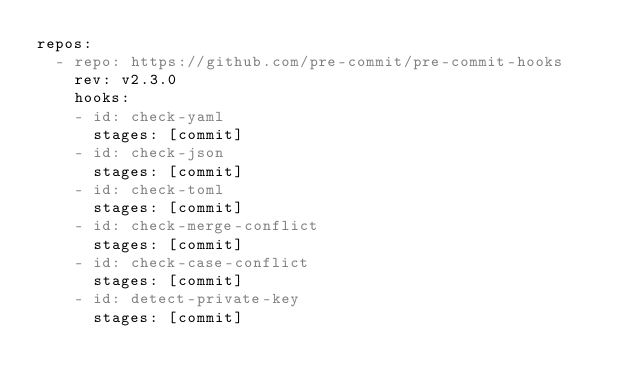Convert code to text. <code><loc_0><loc_0><loc_500><loc_500><_YAML_>repos:
  - repo: https://github.com/pre-commit/pre-commit-hooks
    rev: v2.3.0
    hooks:
    - id: check-yaml
      stages: [commit]
    - id: check-json
      stages: [commit]
    - id: check-toml
      stages: [commit]
    - id: check-merge-conflict
      stages: [commit]
    - id: check-case-conflict
      stages: [commit]
    - id: detect-private-key
      stages: [commit]
</code> 